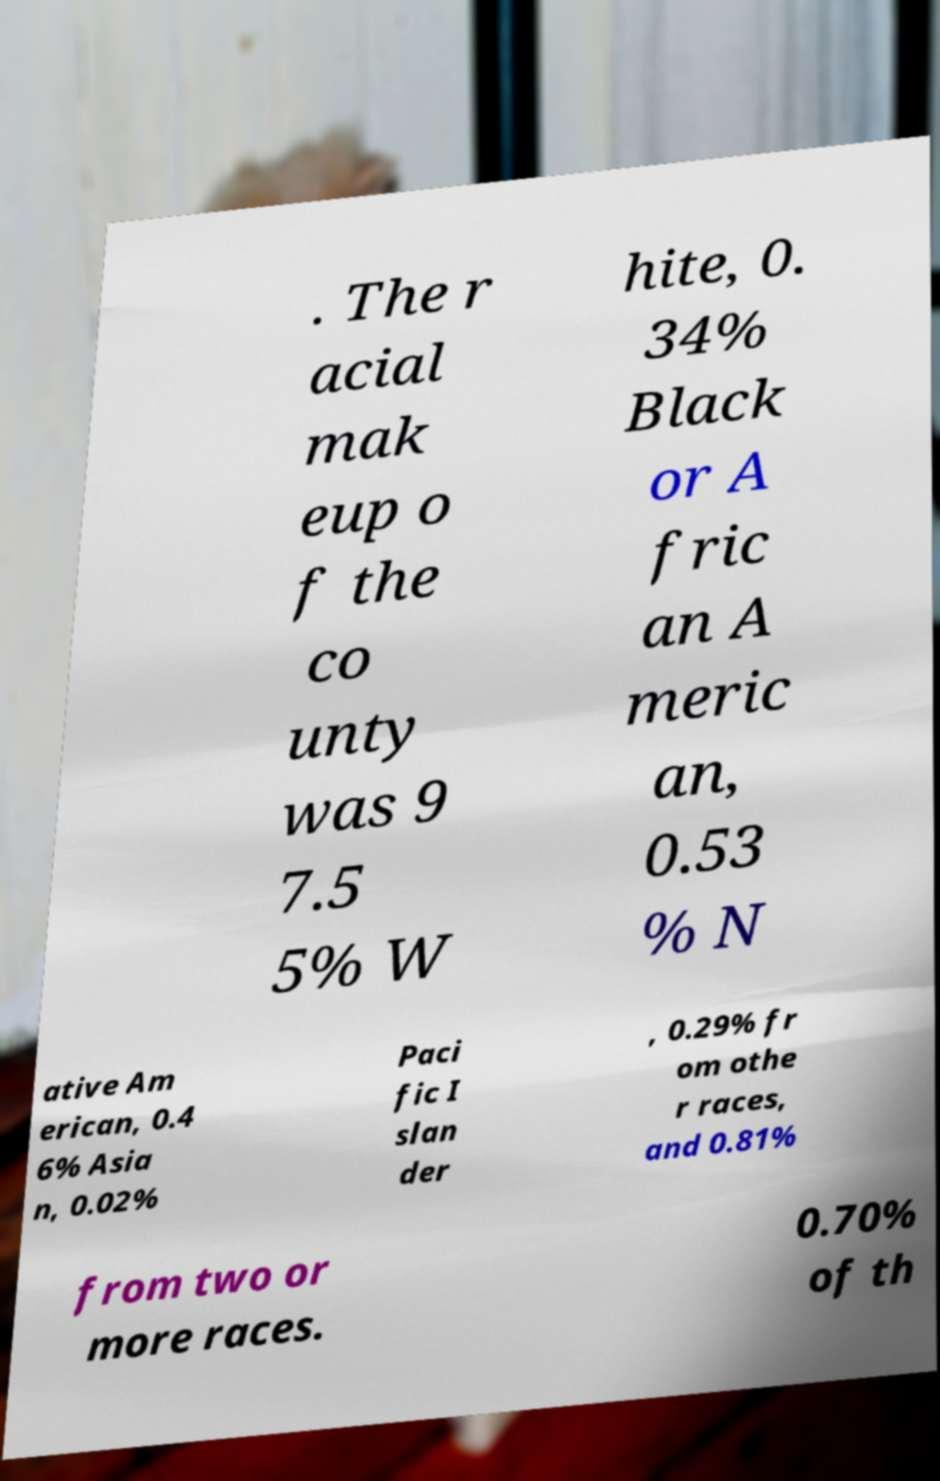Please identify and transcribe the text found in this image. . The r acial mak eup o f the co unty was 9 7.5 5% W hite, 0. 34% Black or A fric an A meric an, 0.53 % N ative Am erican, 0.4 6% Asia n, 0.02% Paci fic I slan der , 0.29% fr om othe r races, and 0.81% from two or more races. 0.70% of th 